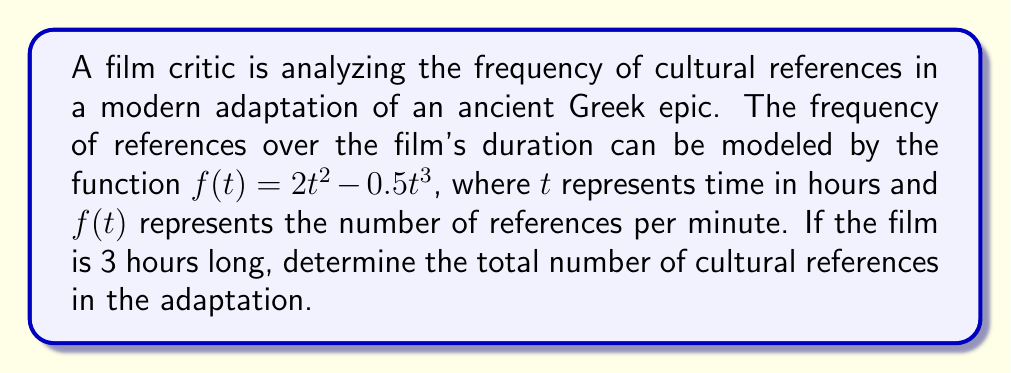Solve this math problem. To solve this problem, we need to find the area under the curve of $f(t)$ from $t=0$ to $t=3$. This can be done using definite integration.

1. Set up the definite integral:
   $$\int_0^3 (2t^2 - 0.5t^3) dt$$

2. Integrate the function:
   $$\int (2t^2 - 0.5t^3) dt = \frac{2t^3}{3} - \frac{0.5t^4}{4} + C$$

3. Apply the limits of integration:
   $$\left[\frac{2t^3}{3} - \frac{0.5t^4}{4}\right]_0^3$$

4. Evaluate at $t=3$ and $t=0$:
   $$\left(\frac{2(3)^3}{3} - \frac{0.5(3)^4}{4}\right) - \left(\frac{2(0)^3}{3} - \frac{0.5(0)^4}{4}\right)$$

5. Simplify:
   $$\left(18 - \frac{40.5}{4}\right) - (0 - 0) = 18 - 10.125 = 7.875$$

6. Convert to total references:
   Since $f(t)$ represents references per minute and we integrated over 3 hours, we need to multiply our result by 60 minutes/hour:
   $$7.875 \times 60 = 472.5$$
Answer: The total number of cultural references in the 3-hour adaptation is approximately 473 references. 